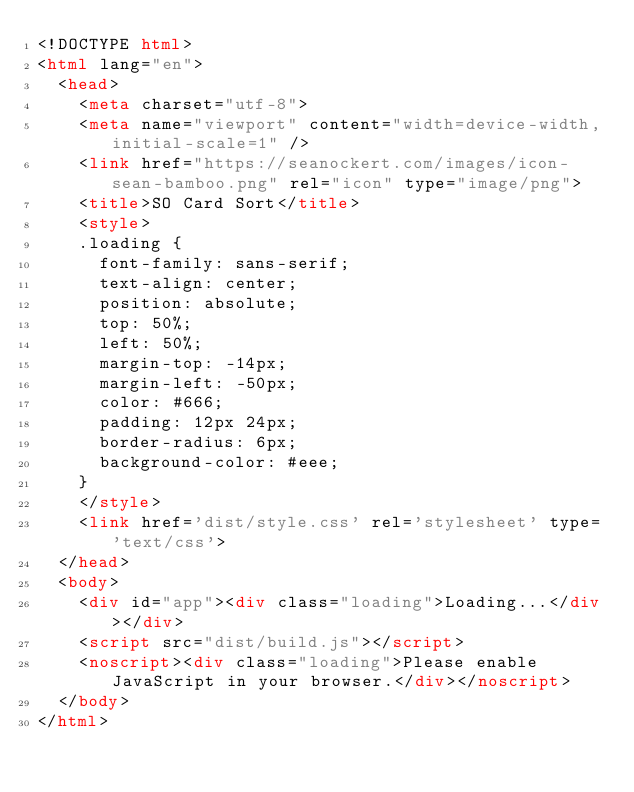<code> <loc_0><loc_0><loc_500><loc_500><_HTML_><!DOCTYPE html>
<html lang="en">
  <head>
  	<meta charset="utf-8">
    <meta name="viewport" content="width=device-width,initial-scale=1" />
    <link href="https://seanockert.com/images/icon-sean-bamboo.png" rel="icon" type="image/png">   
    <title>SO Card Sort</title>
    <style>
    .loading {
      font-family: sans-serif;
      text-align: center;
      position: absolute;
      top: 50%;
      left: 50%;
      margin-top: -14px;
      margin-left: -50px;
      color: #666;
      padding: 12px 24px;
      border-radius: 6px;
      background-color: #eee;
    }
    </style>
    <link href='dist/style.css' rel='stylesheet' type='text/css'>
  </head>
  <body>
    <div id="app"><div class="loading">Loading...</div></div>
    <script src="dist/build.js"></script>
    <noscript><div class="loading">Please enable JavaScript in your browser.</div></noscript>
  </body>
</html></code> 